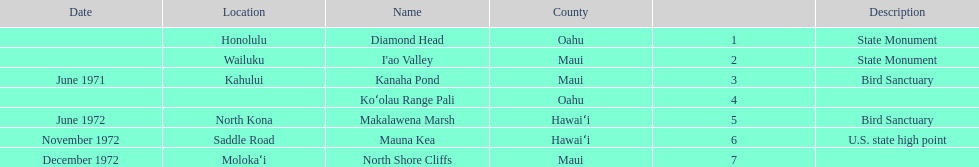What is the total number of state monuments? 2. 